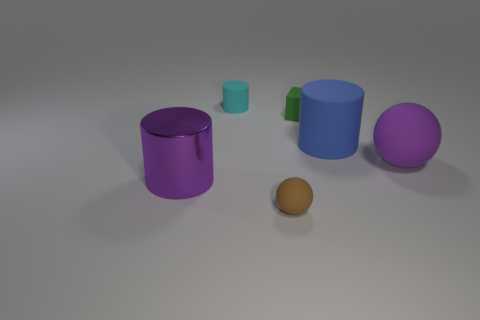Are the objects casting shadows and what does this imply about the light source? Yes, each object casts a distinct shadow. The direction and softness of the shadows indicate that there's a single light source above the objects, likely diffused to create a subtle and uniform lighting effect. 